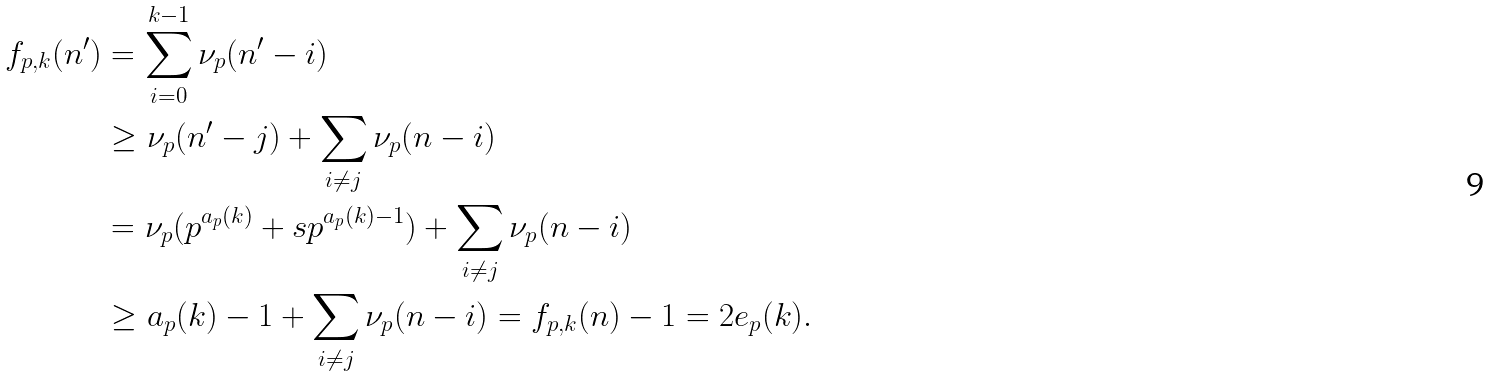<formula> <loc_0><loc_0><loc_500><loc_500>f _ { p , k } ( n ^ { \prime } ) & = \sum _ { i = 0 } ^ { k - 1 } \nu _ { p } ( n ^ { \prime } - i ) \\ & \geq \nu _ { p } ( n ^ { \prime } - j ) + \sum _ { i \neq j } \nu _ { p } ( n - i ) \\ & = \nu _ { p } ( p ^ { a _ { p } ( k ) } + s p ^ { a _ { p } ( k ) - 1 } ) + \sum _ { i \neq j } \nu _ { p } ( n - i ) \\ & \geq a _ { p } ( k ) - 1 + \sum _ { i \neq j } \nu _ { p } ( n - i ) = f _ { p , k } ( n ) - 1 = 2 e _ { p } ( k ) .</formula> 